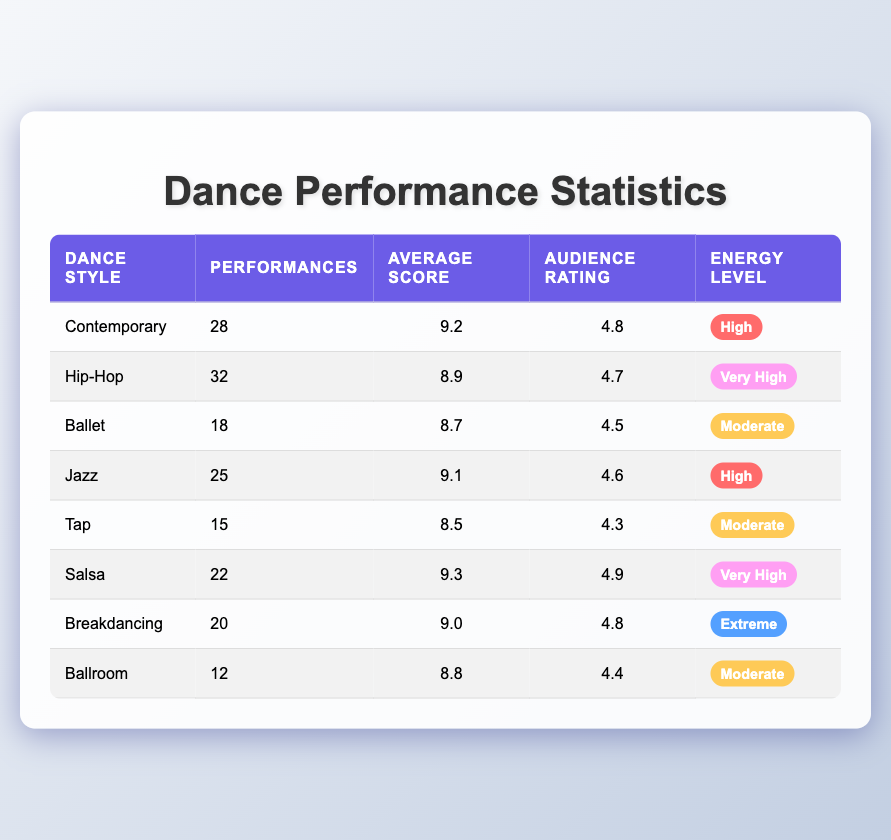What is the average score for the Salsa dance style? The table lists the average score for Salsa as 9.3. I can find this value directly in the corresponding row under the "Average Score" column for Salsa.
Answer: 9.3 How many performances were recorded for Hip-Hop? According to the table, there were 32 performances recorded for Hip-Hop, which can be found directly in its row under the "Performances" column.
Answer: 32 Is the audience rating for Ballet greater than 4.5? The table shows that the audience rating for Ballet is 4.5. Since the question asks if it is greater, and 4.5 is not greater than itself, the answer is no.
Answer: No What is the total number of performances across all dance styles? To find the total number of performances, I will sum all the values in the "Performances" column: 28 + 32 + 18 + 25 + 15 + 22 + 20 + 12 =  182. Now I can conclude that the total number of performances is 182.
Answer: 182 Which dance style has the highest average score, and what is that score? First, I will review the "Average Score" column to find the highest value. The highest score is 9.3, which corresponds to Salsa. Therefore, Salsa has the highest average score of 9.3.
Answer: Salsa, 9.3 What percentage of performances were dedicated to the Contemporary style compared to the overall total? The total number of performances is 182, as calculated earlier. The number of performances in Contemporary is 28. To find the percentage, I use the formula (28/182) * 100 = approximately 15.38%. Thus, approximately 15.38% of the performances were in Contemporary style.
Answer: 15.38% Are there more than 20 performances in Jazz? The table lists 25 performances for Jazz, which is greater than 20. Therefore, the answer is yes.
Answer: Yes What is the average audience rating for the dance styles with a "Very High" energy level? The dance styles with a "Very High" energy level are Hip-Hop and Salsa. Their audience ratings are 4.7 and 4.9, respectively. To find the average, I can sum these values (4.7 + 4.9 = 9.6) and divide by the number of styles (2): 9.6 / 2 = 4.8. The average audience rating for the Very High energy level styles is 4.8.
Answer: 4.8 Which dance style with a "Moderate" energy level had the least performances? The dance styles listed under "Moderate" energy level are Ballet, Tap, and Ballroom, with 18, 15, and 12 performances respectively. Among these, Ballroom has the least performances at 12.
Answer: Ballroom, 12 